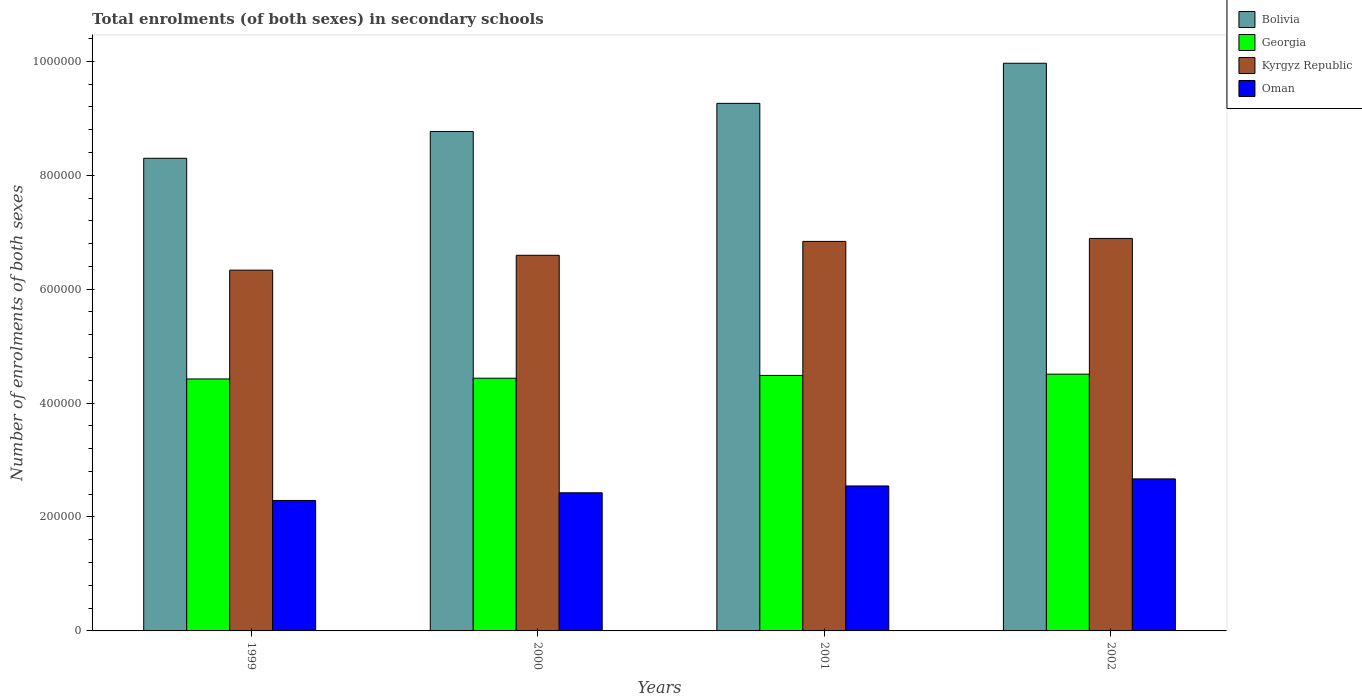How many bars are there on the 3rd tick from the left?
Ensure brevity in your answer.  4. What is the label of the 3rd group of bars from the left?
Offer a terse response. 2001. In how many cases, is the number of bars for a given year not equal to the number of legend labels?
Your answer should be compact. 0. What is the number of enrolments in secondary schools in Oman in 1999?
Offer a very short reply. 2.29e+05. Across all years, what is the maximum number of enrolments in secondary schools in Georgia?
Provide a short and direct response. 4.51e+05. Across all years, what is the minimum number of enrolments in secondary schools in Bolivia?
Give a very brief answer. 8.30e+05. What is the total number of enrolments in secondary schools in Kyrgyz Republic in the graph?
Offer a very short reply. 2.67e+06. What is the difference between the number of enrolments in secondary schools in Georgia in 1999 and that in 2001?
Your answer should be compact. -6191. What is the difference between the number of enrolments in secondary schools in Georgia in 2002 and the number of enrolments in secondary schools in Bolivia in 1999?
Your answer should be very brief. -3.79e+05. What is the average number of enrolments in secondary schools in Oman per year?
Provide a short and direct response. 2.48e+05. In the year 2002, what is the difference between the number of enrolments in secondary schools in Kyrgyz Republic and number of enrolments in secondary schools in Georgia?
Make the answer very short. 2.38e+05. What is the ratio of the number of enrolments in secondary schools in Oman in 1999 to that in 2000?
Keep it short and to the point. 0.94. Is the difference between the number of enrolments in secondary schools in Kyrgyz Republic in 2000 and 2002 greater than the difference between the number of enrolments in secondary schools in Georgia in 2000 and 2002?
Your answer should be very brief. No. What is the difference between the highest and the second highest number of enrolments in secondary schools in Oman?
Your answer should be compact. 1.24e+04. What is the difference between the highest and the lowest number of enrolments in secondary schools in Georgia?
Offer a terse response. 8414. In how many years, is the number of enrolments in secondary schools in Georgia greater than the average number of enrolments in secondary schools in Georgia taken over all years?
Make the answer very short. 2. Is the sum of the number of enrolments in secondary schools in Georgia in 1999 and 2002 greater than the maximum number of enrolments in secondary schools in Kyrgyz Republic across all years?
Your answer should be compact. Yes. What does the 3rd bar from the left in 2001 represents?
Offer a terse response. Kyrgyz Republic. What does the 1st bar from the right in 2000 represents?
Offer a terse response. Oman. Is it the case that in every year, the sum of the number of enrolments in secondary schools in Bolivia and number of enrolments in secondary schools in Oman is greater than the number of enrolments in secondary schools in Kyrgyz Republic?
Keep it short and to the point. Yes. How many bars are there?
Your answer should be very brief. 16. Are all the bars in the graph horizontal?
Provide a short and direct response. No. How many years are there in the graph?
Make the answer very short. 4. Does the graph contain grids?
Offer a very short reply. No. How are the legend labels stacked?
Make the answer very short. Vertical. What is the title of the graph?
Offer a terse response. Total enrolments (of both sexes) in secondary schools. What is the label or title of the Y-axis?
Your answer should be compact. Number of enrolments of both sexes. What is the Number of enrolments of both sexes of Bolivia in 1999?
Give a very brief answer. 8.30e+05. What is the Number of enrolments of both sexes in Georgia in 1999?
Provide a short and direct response. 4.42e+05. What is the Number of enrolments of both sexes of Kyrgyz Republic in 1999?
Offer a very short reply. 6.33e+05. What is the Number of enrolments of both sexes of Oman in 1999?
Your answer should be compact. 2.29e+05. What is the Number of enrolments of both sexes of Bolivia in 2000?
Offer a terse response. 8.77e+05. What is the Number of enrolments of both sexes in Georgia in 2000?
Ensure brevity in your answer.  4.44e+05. What is the Number of enrolments of both sexes in Kyrgyz Republic in 2000?
Offer a very short reply. 6.59e+05. What is the Number of enrolments of both sexes in Oman in 2000?
Give a very brief answer. 2.43e+05. What is the Number of enrolments of both sexes in Bolivia in 2001?
Your answer should be compact. 9.26e+05. What is the Number of enrolments of both sexes in Georgia in 2001?
Give a very brief answer. 4.49e+05. What is the Number of enrolments of both sexes of Kyrgyz Republic in 2001?
Provide a short and direct response. 6.84e+05. What is the Number of enrolments of both sexes in Oman in 2001?
Give a very brief answer. 2.54e+05. What is the Number of enrolments of both sexes in Bolivia in 2002?
Provide a short and direct response. 9.97e+05. What is the Number of enrolments of both sexes in Georgia in 2002?
Offer a very short reply. 4.51e+05. What is the Number of enrolments of both sexes of Kyrgyz Republic in 2002?
Your response must be concise. 6.89e+05. What is the Number of enrolments of both sexes of Oman in 2002?
Make the answer very short. 2.67e+05. Across all years, what is the maximum Number of enrolments of both sexes of Bolivia?
Keep it short and to the point. 9.97e+05. Across all years, what is the maximum Number of enrolments of both sexes in Georgia?
Keep it short and to the point. 4.51e+05. Across all years, what is the maximum Number of enrolments of both sexes in Kyrgyz Republic?
Give a very brief answer. 6.89e+05. Across all years, what is the maximum Number of enrolments of both sexes in Oman?
Make the answer very short. 2.67e+05. Across all years, what is the minimum Number of enrolments of both sexes in Bolivia?
Offer a very short reply. 8.30e+05. Across all years, what is the minimum Number of enrolments of both sexes of Georgia?
Keep it short and to the point. 4.42e+05. Across all years, what is the minimum Number of enrolments of both sexes in Kyrgyz Republic?
Ensure brevity in your answer.  6.33e+05. Across all years, what is the minimum Number of enrolments of both sexes of Oman?
Your answer should be compact. 2.29e+05. What is the total Number of enrolments of both sexes of Bolivia in the graph?
Provide a succinct answer. 3.63e+06. What is the total Number of enrolments of both sexes of Georgia in the graph?
Provide a succinct answer. 1.79e+06. What is the total Number of enrolments of both sexes in Kyrgyz Republic in the graph?
Provide a succinct answer. 2.67e+06. What is the total Number of enrolments of both sexes of Oman in the graph?
Provide a succinct answer. 9.93e+05. What is the difference between the Number of enrolments of both sexes in Bolivia in 1999 and that in 2000?
Your answer should be compact. -4.71e+04. What is the difference between the Number of enrolments of both sexes in Georgia in 1999 and that in 2000?
Your answer should be very brief. -1270. What is the difference between the Number of enrolments of both sexes in Kyrgyz Republic in 1999 and that in 2000?
Your answer should be very brief. -2.61e+04. What is the difference between the Number of enrolments of both sexes of Oman in 1999 and that in 2000?
Keep it short and to the point. -1.35e+04. What is the difference between the Number of enrolments of both sexes of Bolivia in 1999 and that in 2001?
Your answer should be very brief. -9.64e+04. What is the difference between the Number of enrolments of both sexes in Georgia in 1999 and that in 2001?
Give a very brief answer. -6191. What is the difference between the Number of enrolments of both sexes in Kyrgyz Republic in 1999 and that in 2001?
Give a very brief answer. -5.05e+04. What is the difference between the Number of enrolments of both sexes in Oman in 1999 and that in 2001?
Make the answer very short. -2.55e+04. What is the difference between the Number of enrolments of both sexes in Bolivia in 1999 and that in 2002?
Provide a succinct answer. -1.67e+05. What is the difference between the Number of enrolments of both sexes in Georgia in 1999 and that in 2002?
Offer a terse response. -8414. What is the difference between the Number of enrolments of both sexes in Kyrgyz Republic in 1999 and that in 2002?
Ensure brevity in your answer.  -5.57e+04. What is the difference between the Number of enrolments of both sexes of Oman in 1999 and that in 2002?
Offer a very short reply. -3.79e+04. What is the difference between the Number of enrolments of both sexes of Bolivia in 2000 and that in 2001?
Your response must be concise. -4.93e+04. What is the difference between the Number of enrolments of both sexes of Georgia in 2000 and that in 2001?
Your answer should be compact. -4921. What is the difference between the Number of enrolments of both sexes of Kyrgyz Republic in 2000 and that in 2001?
Your answer should be compact. -2.44e+04. What is the difference between the Number of enrolments of both sexes of Oman in 2000 and that in 2001?
Provide a succinct answer. -1.20e+04. What is the difference between the Number of enrolments of both sexes in Bolivia in 2000 and that in 2002?
Offer a very short reply. -1.20e+05. What is the difference between the Number of enrolments of both sexes of Georgia in 2000 and that in 2002?
Your answer should be compact. -7144. What is the difference between the Number of enrolments of both sexes in Kyrgyz Republic in 2000 and that in 2002?
Make the answer very short. -2.96e+04. What is the difference between the Number of enrolments of both sexes in Oman in 2000 and that in 2002?
Provide a short and direct response. -2.44e+04. What is the difference between the Number of enrolments of both sexes in Bolivia in 2001 and that in 2002?
Your answer should be compact. -7.04e+04. What is the difference between the Number of enrolments of both sexes of Georgia in 2001 and that in 2002?
Make the answer very short. -2223. What is the difference between the Number of enrolments of both sexes of Kyrgyz Republic in 2001 and that in 2002?
Your response must be concise. -5204. What is the difference between the Number of enrolments of both sexes in Oman in 2001 and that in 2002?
Give a very brief answer. -1.24e+04. What is the difference between the Number of enrolments of both sexes in Bolivia in 1999 and the Number of enrolments of both sexes in Georgia in 2000?
Provide a succinct answer. 3.86e+05. What is the difference between the Number of enrolments of both sexes of Bolivia in 1999 and the Number of enrolments of both sexes of Kyrgyz Republic in 2000?
Give a very brief answer. 1.70e+05. What is the difference between the Number of enrolments of both sexes of Bolivia in 1999 and the Number of enrolments of both sexes of Oman in 2000?
Keep it short and to the point. 5.87e+05. What is the difference between the Number of enrolments of both sexes of Georgia in 1999 and the Number of enrolments of both sexes of Kyrgyz Republic in 2000?
Ensure brevity in your answer.  -2.17e+05. What is the difference between the Number of enrolments of both sexes in Georgia in 1999 and the Number of enrolments of both sexes in Oman in 2000?
Offer a terse response. 2.00e+05. What is the difference between the Number of enrolments of both sexes in Kyrgyz Republic in 1999 and the Number of enrolments of both sexes in Oman in 2000?
Offer a terse response. 3.91e+05. What is the difference between the Number of enrolments of both sexes in Bolivia in 1999 and the Number of enrolments of both sexes in Georgia in 2001?
Give a very brief answer. 3.81e+05. What is the difference between the Number of enrolments of both sexes of Bolivia in 1999 and the Number of enrolments of both sexes of Kyrgyz Republic in 2001?
Provide a succinct answer. 1.46e+05. What is the difference between the Number of enrolments of both sexes of Bolivia in 1999 and the Number of enrolments of both sexes of Oman in 2001?
Provide a succinct answer. 5.75e+05. What is the difference between the Number of enrolments of both sexes in Georgia in 1999 and the Number of enrolments of both sexes in Kyrgyz Republic in 2001?
Your answer should be very brief. -2.41e+05. What is the difference between the Number of enrolments of both sexes of Georgia in 1999 and the Number of enrolments of both sexes of Oman in 2001?
Provide a succinct answer. 1.88e+05. What is the difference between the Number of enrolments of both sexes of Kyrgyz Republic in 1999 and the Number of enrolments of both sexes of Oman in 2001?
Ensure brevity in your answer.  3.79e+05. What is the difference between the Number of enrolments of both sexes of Bolivia in 1999 and the Number of enrolments of both sexes of Georgia in 2002?
Your answer should be compact. 3.79e+05. What is the difference between the Number of enrolments of both sexes in Bolivia in 1999 and the Number of enrolments of both sexes in Kyrgyz Republic in 2002?
Your answer should be very brief. 1.41e+05. What is the difference between the Number of enrolments of both sexes in Bolivia in 1999 and the Number of enrolments of both sexes in Oman in 2002?
Offer a terse response. 5.63e+05. What is the difference between the Number of enrolments of both sexes in Georgia in 1999 and the Number of enrolments of both sexes in Kyrgyz Republic in 2002?
Your answer should be very brief. -2.47e+05. What is the difference between the Number of enrolments of both sexes of Georgia in 1999 and the Number of enrolments of both sexes of Oman in 2002?
Keep it short and to the point. 1.75e+05. What is the difference between the Number of enrolments of both sexes of Kyrgyz Republic in 1999 and the Number of enrolments of both sexes of Oman in 2002?
Give a very brief answer. 3.66e+05. What is the difference between the Number of enrolments of both sexes of Bolivia in 2000 and the Number of enrolments of both sexes of Georgia in 2001?
Offer a very short reply. 4.28e+05. What is the difference between the Number of enrolments of both sexes in Bolivia in 2000 and the Number of enrolments of both sexes in Kyrgyz Republic in 2001?
Your answer should be very brief. 1.93e+05. What is the difference between the Number of enrolments of both sexes in Bolivia in 2000 and the Number of enrolments of both sexes in Oman in 2001?
Keep it short and to the point. 6.22e+05. What is the difference between the Number of enrolments of both sexes of Georgia in 2000 and the Number of enrolments of both sexes of Kyrgyz Republic in 2001?
Offer a very short reply. -2.40e+05. What is the difference between the Number of enrolments of both sexes in Georgia in 2000 and the Number of enrolments of both sexes in Oman in 2001?
Keep it short and to the point. 1.89e+05. What is the difference between the Number of enrolments of both sexes in Kyrgyz Republic in 2000 and the Number of enrolments of both sexes in Oman in 2001?
Your answer should be very brief. 4.05e+05. What is the difference between the Number of enrolments of both sexes in Bolivia in 2000 and the Number of enrolments of both sexes in Georgia in 2002?
Your response must be concise. 4.26e+05. What is the difference between the Number of enrolments of both sexes of Bolivia in 2000 and the Number of enrolments of both sexes of Kyrgyz Republic in 2002?
Your answer should be very brief. 1.88e+05. What is the difference between the Number of enrolments of both sexes in Bolivia in 2000 and the Number of enrolments of both sexes in Oman in 2002?
Make the answer very short. 6.10e+05. What is the difference between the Number of enrolments of both sexes in Georgia in 2000 and the Number of enrolments of both sexes in Kyrgyz Republic in 2002?
Give a very brief answer. -2.45e+05. What is the difference between the Number of enrolments of both sexes in Georgia in 2000 and the Number of enrolments of both sexes in Oman in 2002?
Offer a very short reply. 1.77e+05. What is the difference between the Number of enrolments of both sexes in Kyrgyz Republic in 2000 and the Number of enrolments of both sexes in Oman in 2002?
Offer a terse response. 3.93e+05. What is the difference between the Number of enrolments of both sexes in Bolivia in 2001 and the Number of enrolments of both sexes in Georgia in 2002?
Your answer should be compact. 4.75e+05. What is the difference between the Number of enrolments of both sexes of Bolivia in 2001 and the Number of enrolments of both sexes of Kyrgyz Republic in 2002?
Your response must be concise. 2.37e+05. What is the difference between the Number of enrolments of both sexes in Bolivia in 2001 and the Number of enrolments of both sexes in Oman in 2002?
Your response must be concise. 6.59e+05. What is the difference between the Number of enrolments of both sexes in Georgia in 2001 and the Number of enrolments of both sexes in Kyrgyz Republic in 2002?
Ensure brevity in your answer.  -2.40e+05. What is the difference between the Number of enrolments of both sexes in Georgia in 2001 and the Number of enrolments of both sexes in Oman in 2002?
Your answer should be very brief. 1.82e+05. What is the difference between the Number of enrolments of both sexes of Kyrgyz Republic in 2001 and the Number of enrolments of both sexes of Oman in 2002?
Keep it short and to the point. 4.17e+05. What is the average Number of enrolments of both sexes of Bolivia per year?
Keep it short and to the point. 9.07e+05. What is the average Number of enrolments of both sexes in Georgia per year?
Your answer should be very brief. 4.46e+05. What is the average Number of enrolments of both sexes in Kyrgyz Republic per year?
Give a very brief answer. 6.66e+05. What is the average Number of enrolments of both sexes of Oman per year?
Ensure brevity in your answer.  2.48e+05. In the year 1999, what is the difference between the Number of enrolments of both sexes of Bolivia and Number of enrolments of both sexes of Georgia?
Give a very brief answer. 3.87e+05. In the year 1999, what is the difference between the Number of enrolments of both sexes of Bolivia and Number of enrolments of both sexes of Kyrgyz Republic?
Your answer should be very brief. 1.96e+05. In the year 1999, what is the difference between the Number of enrolments of both sexes in Bolivia and Number of enrolments of both sexes in Oman?
Keep it short and to the point. 6.01e+05. In the year 1999, what is the difference between the Number of enrolments of both sexes of Georgia and Number of enrolments of both sexes of Kyrgyz Republic?
Your answer should be compact. -1.91e+05. In the year 1999, what is the difference between the Number of enrolments of both sexes in Georgia and Number of enrolments of both sexes in Oman?
Offer a very short reply. 2.13e+05. In the year 1999, what is the difference between the Number of enrolments of both sexes in Kyrgyz Republic and Number of enrolments of both sexes in Oman?
Offer a very short reply. 4.04e+05. In the year 2000, what is the difference between the Number of enrolments of both sexes of Bolivia and Number of enrolments of both sexes of Georgia?
Provide a short and direct response. 4.33e+05. In the year 2000, what is the difference between the Number of enrolments of both sexes in Bolivia and Number of enrolments of both sexes in Kyrgyz Republic?
Ensure brevity in your answer.  2.17e+05. In the year 2000, what is the difference between the Number of enrolments of both sexes of Bolivia and Number of enrolments of both sexes of Oman?
Your response must be concise. 6.34e+05. In the year 2000, what is the difference between the Number of enrolments of both sexes in Georgia and Number of enrolments of both sexes in Kyrgyz Republic?
Provide a succinct answer. -2.16e+05. In the year 2000, what is the difference between the Number of enrolments of both sexes in Georgia and Number of enrolments of both sexes in Oman?
Provide a succinct answer. 2.01e+05. In the year 2000, what is the difference between the Number of enrolments of both sexes of Kyrgyz Republic and Number of enrolments of both sexes of Oman?
Give a very brief answer. 4.17e+05. In the year 2001, what is the difference between the Number of enrolments of both sexes of Bolivia and Number of enrolments of both sexes of Georgia?
Ensure brevity in your answer.  4.78e+05. In the year 2001, what is the difference between the Number of enrolments of both sexes in Bolivia and Number of enrolments of both sexes in Kyrgyz Republic?
Your answer should be very brief. 2.42e+05. In the year 2001, what is the difference between the Number of enrolments of both sexes of Bolivia and Number of enrolments of both sexes of Oman?
Keep it short and to the point. 6.72e+05. In the year 2001, what is the difference between the Number of enrolments of both sexes in Georgia and Number of enrolments of both sexes in Kyrgyz Republic?
Give a very brief answer. -2.35e+05. In the year 2001, what is the difference between the Number of enrolments of both sexes in Georgia and Number of enrolments of both sexes in Oman?
Ensure brevity in your answer.  1.94e+05. In the year 2001, what is the difference between the Number of enrolments of both sexes of Kyrgyz Republic and Number of enrolments of both sexes of Oman?
Provide a succinct answer. 4.29e+05. In the year 2002, what is the difference between the Number of enrolments of both sexes in Bolivia and Number of enrolments of both sexes in Georgia?
Offer a terse response. 5.46e+05. In the year 2002, what is the difference between the Number of enrolments of both sexes of Bolivia and Number of enrolments of both sexes of Kyrgyz Republic?
Make the answer very short. 3.08e+05. In the year 2002, what is the difference between the Number of enrolments of both sexes of Bolivia and Number of enrolments of both sexes of Oman?
Give a very brief answer. 7.30e+05. In the year 2002, what is the difference between the Number of enrolments of both sexes of Georgia and Number of enrolments of both sexes of Kyrgyz Republic?
Offer a terse response. -2.38e+05. In the year 2002, what is the difference between the Number of enrolments of both sexes in Georgia and Number of enrolments of both sexes in Oman?
Provide a short and direct response. 1.84e+05. In the year 2002, what is the difference between the Number of enrolments of both sexes of Kyrgyz Republic and Number of enrolments of both sexes of Oman?
Your answer should be very brief. 4.22e+05. What is the ratio of the Number of enrolments of both sexes of Bolivia in 1999 to that in 2000?
Your answer should be compact. 0.95. What is the ratio of the Number of enrolments of both sexes of Kyrgyz Republic in 1999 to that in 2000?
Your response must be concise. 0.96. What is the ratio of the Number of enrolments of both sexes in Oman in 1999 to that in 2000?
Your response must be concise. 0.94. What is the ratio of the Number of enrolments of both sexes of Bolivia in 1999 to that in 2001?
Provide a succinct answer. 0.9. What is the ratio of the Number of enrolments of both sexes in Georgia in 1999 to that in 2001?
Your answer should be very brief. 0.99. What is the ratio of the Number of enrolments of both sexes in Kyrgyz Republic in 1999 to that in 2001?
Provide a short and direct response. 0.93. What is the ratio of the Number of enrolments of both sexes in Oman in 1999 to that in 2001?
Give a very brief answer. 0.9. What is the ratio of the Number of enrolments of both sexes in Bolivia in 1999 to that in 2002?
Give a very brief answer. 0.83. What is the ratio of the Number of enrolments of both sexes of Georgia in 1999 to that in 2002?
Provide a succinct answer. 0.98. What is the ratio of the Number of enrolments of both sexes in Kyrgyz Republic in 1999 to that in 2002?
Offer a terse response. 0.92. What is the ratio of the Number of enrolments of both sexes in Oman in 1999 to that in 2002?
Ensure brevity in your answer.  0.86. What is the ratio of the Number of enrolments of both sexes in Bolivia in 2000 to that in 2001?
Your response must be concise. 0.95. What is the ratio of the Number of enrolments of both sexes of Georgia in 2000 to that in 2001?
Make the answer very short. 0.99. What is the ratio of the Number of enrolments of both sexes in Oman in 2000 to that in 2001?
Give a very brief answer. 0.95. What is the ratio of the Number of enrolments of both sexes of Bolivia in 2000 to that in 2002?
Offer a terse response. 0.88. What is the ratio of the Number of enrolments of both sexes of Georgia in 2000 to that in 2002?
Your answer should be compact. 0.98. What is the ratio of the Number of enrolments of both sexes in Kyrgyz Republic in 2000 to that in 2002?
Your answer should be very brief. 0.96. What is the ratio of the Number of enrolments of both sexes in Oman in 2000 to that in 2002?
Make the answer very short. 0.91. What is the ratio of the Number of enrolments of both sexes in Bolivia in 2001 to that in 2002?
Your answer should be compact. 0.93. What is the ratio of the Number of enrolments of both sexes of Oman in 2001 to that in 2002?
Provide a short and direct response. 0.95. What is the difference between the highest and the second highest Number of enrolments of both sexes in Bolivia?
Ensure brevity in your answer.  7.04e+04. What is the difference between the highest and the second highest Number of enrolments of both sexes of Georgia?
Your answer should be compact. 2223. What is the difference between the highest and the second highest Number of enrolments of both sexes in Kyrgyz Republic?
Your response must be concise. 5204. What is the difference between the highest and the second highest Number of enrolments of both sexes in Oman?
Ensure brevity in your answer.  1.24e+04. What is the difference between the highest and the lowest Number of enrolments of both sexes of Bolivia?
Offer a very short reply. 1.67e+05. What is the difference between the highest and the lowest Number of enrolments of both sexes of Georgia?
Offer a very short reply. 8414. What is the difference between the highest and the lowest Number of enrolments of both sexes of Kyrgyz Republic?
Ensure brevity in your answer.  5.57e+04. What is the difference between the highest and the lowest Number of enrolments of both sexes in Oman?
Your answer should be compact. 3.79e+04. 